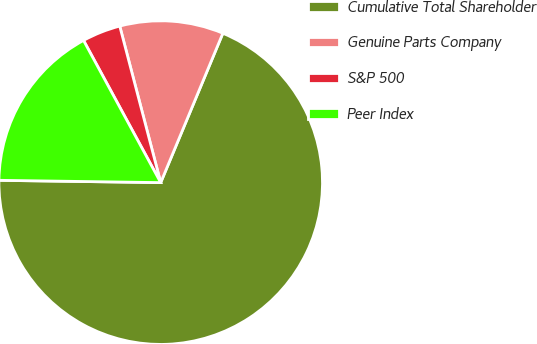Convert chart. <chart><loc_0><loc_0><loc_500><loc_500><pie_chart><fcel>Cumulative Total Shareholder<fcel>Genuine Parts Company<fcel>S&P 500<fcel>Peer Index<nl><fcel>68.95%<fcel>10.35%<fcel>3.84%<fcel>16.86%<nl></chart> 